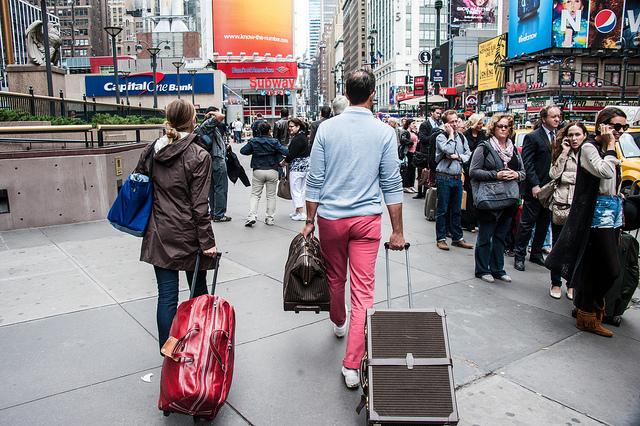What bank name is shown on the left side?
Be succinct. Capital one. What color are the man's pants?
Answer briefly. Pink. What color is the suitcase on the left?
Keep it brief. Red. 